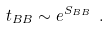<formula> <loc_0><loc_0><loc_500><loc_500>t _ { B B } \sim e ^ { S _ { B B } } \ .</formula> 